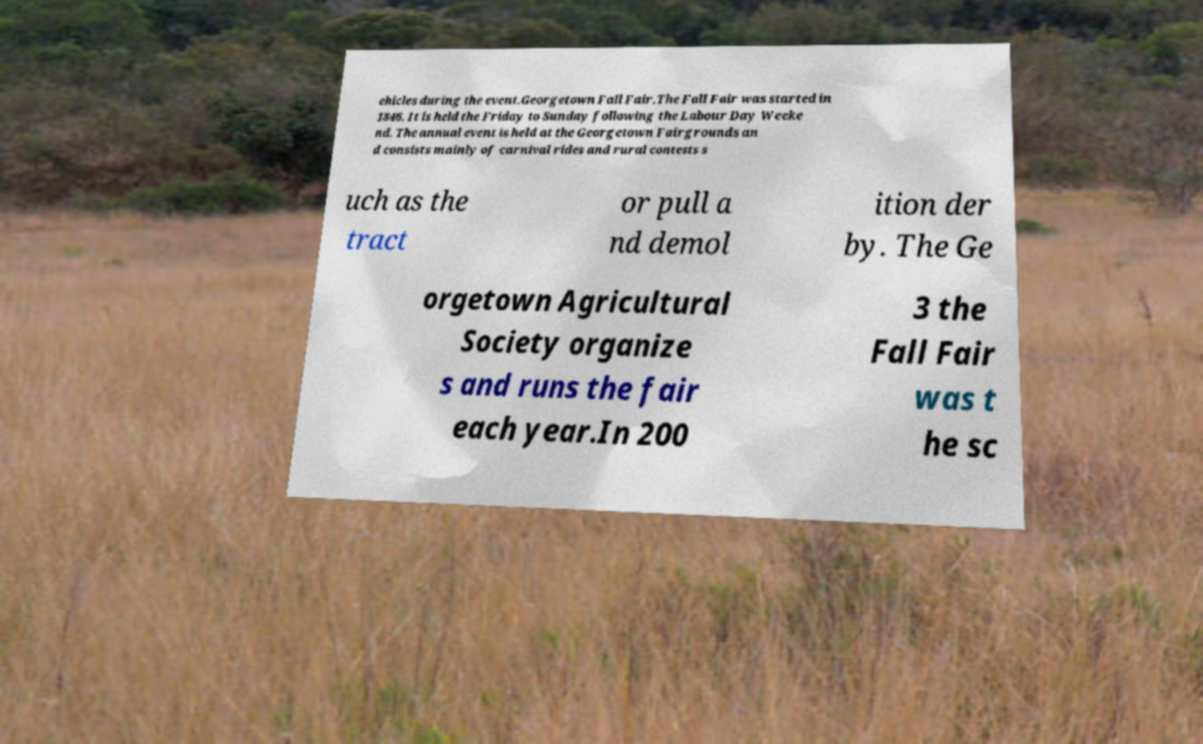Could you assist in decoding the text presented in this image and type it out clearly? ehicles during the event.Georgetown Fall Fair.The Fall Fair was started in 1846. It is held the Friday to Sunday following the Labour Day Weeke nd. The annual event is held at the Georgetown Fairgrounds an d consists mainly of carnival rides and rural contests s uch as the tract or pull a nd demol ition der by. The Ge orgetown Agricultural Society organize s and runs the fair each year.In 200 3 the Fall Fair was t he sc 